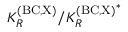<formula> <loc_0><loc_0><loc_500><loc_500>K _ { R } ^ { ( B C , X ) } / { K _ { R } ^ { ( B C , X ) } } ^ { * }</formula> 